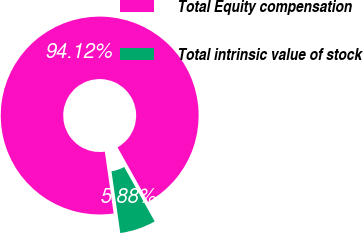<chart> <loc_0><loc_0><loc_500><loc_500><pie_chart><fcel>Total Equity compensation<fcel>Total intrinsic value of stock<nl><fcel>94.12%<fcel>5.88%<nl></chart> 